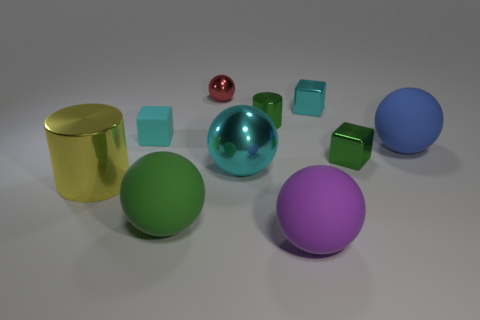Subtract all tiny green blocks. How many blocks are left? 2 Subtract all cylinders. How many objects are left? 8 Subtract all green spheres. How many spheres are left? 4 Subtract all yellow blocks. Subtract all blue balls. How many blocks are left? 3 Subtract all purple cubes. How many green cylinders are left? 1 Subtract all small rubber balls. Subtract all cyan matte objects. How many objects are left? 9 Add 2 big cyan spheres. How many big cyan spheres are left? 3 Add 1 blue metal cubes. How many blue metal cubes exist? 1 Subtract 0 red blocks. How many objects are left? 10 Subtract 3 blocks. How many blocks are left? 0 